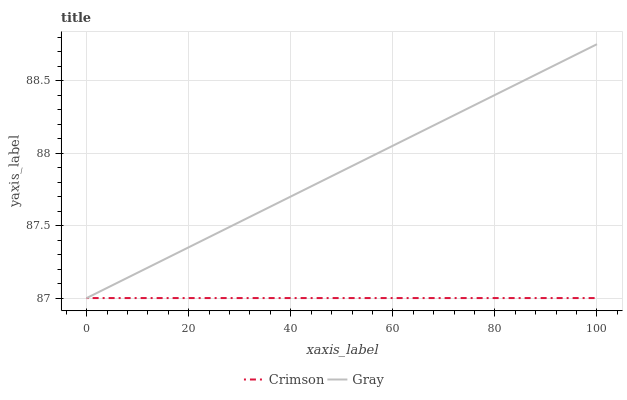Does Crimson have the minimum area under the curve?
Answer yes or no. Yes. Does Gray have the maximum area under the curve?
Answer yes or no. Yes. Does Gray have the minimum area under the curve?
Answer yes or no. No. Is Crimson the smoothest?
Answer yes or no. Yes. Is Gray the roughest?
Answer yes or no. Yes. Is Gray the smoothest?
Answer yes or no. No. 